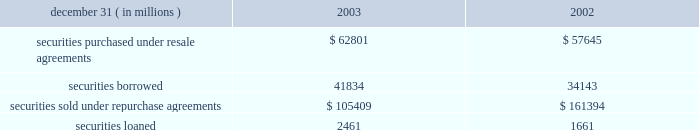Notes to consolidated financial statements j.p .
Morgan chase & co .
98 j.p .
Morgan chase & co .
/ 2003 annual report securities financing activities jpmorgan chase enters into resale agreements , repurchase agreements , securities borrowed transactions and securities loaned transactions primarily to finance the firm 2019s inventory positions , acquire securities to cover short positions and settle other securities obligations .
The firm also enters into these transactions to accommodate customers 2019 needs .
Securities purchased under resale agreements ( 201cresale agreements 201d ) and securities sold under repurchase agreements ( 201crepurchase agreements 201d ) are generally treated as collateralized financing transactions and are carried on the consolidated bal- ance sheet at the amounts the securities will be subsequently sold or repurchased , plus accrued interest .
Where appropriate , resale and repurchase agreements with the same counterparty are reported on a net basis in accordance with fin 41 .
Jpmorgan chase takes possession of securities purchased under resale agreements .
On a daily basis , jpmorgan chase monitors the market value of the underlying collateral received from its counterparties , consisting primarily of u.s .
And non-u.s .
Govern- ment and agency securities , and requests additional collateral from its counterparties when necessary .
Similar transactions that do not meet the sfas 140 definition of a repurchase agreement are accounted for as 201cbuys 201d and 201csells 201d rather than financing transactions .
These transactions are accounted for as a purchase ( sale ) of the underlying securities with a forward obligation to sell ( purchase ) the securities .
The forward purchase ( sale ) obligation , a derivative , is recorded on the consolidated balance sheet at its fair value , with changes in fair value recorded in trading revenue .
Notional amounts of these transactions accounted for as purchases under sfas 140 were $ 15 billion and $ 8 billion at december 31 , 2003 and 2002 , respectively .
Notional amounts of these transactions accounted for as sales under sfas 140 were $ 8 billion and $ 13 billion at december 31 , 2003 and 2002 , respectively .
Based on the short-term duration of these contracts , the unrealized gain or loss is insignificant .
Securities borrowed and securities lent are recorded at the amount of cash collateral advanced or received .
Securities bor- rowed consist primarily of government and equity securities .
Jpmorgan chase monitors the market value of the securities borrowed and lent on a daily basis and calls for additional col- lateral when appropriate .
Fees received or paid are recorded in interest income or interest expense. .
Note 10 jpmorgan chase pledges certain financial instruments it owns to collateralize repurchase agreements and other securities financ- ings .
Pledged securities that can be sold or repledged by the secured party are identified as financial instruments owned ( pledged to various parties ) on the consolidated balance sheet .
At december 31 , 2003 , the firm had received securities as col- lateral that can be repledged , delivered or otherwise used with a fair value of approximately $ 210 billion .
This collateral was gen- erally obtained under resale or securities-borrowing agreements .
Of these securities , approximately $ 197 billion was repledged , delivered or otherwise used , generally as collateral under repur- chase agreements , securities-lending agreements or to cover short sales .
Notes to consolidated financial statements j.p .
Morgan chase & co .
Loans are reported at the principal amount outstanding , net of the allowance for loan losses , unearned income and any net deferred loan fees .
Loans held for sale are carried at the lower of aggregate cost or fair value .
Loans are classified as 201ctrading 201d for secondary market trading activities where positions are bought and sold to make profits from short-term movements in price .
Loans held for trading purposes are included in trading assets and are carried at fair value , with the gains and losses included in trading revenue .
Interest income is recognized using the interest method , or on a basis approximating a level rate of return over the term of the loan .
Nonaccrual loans are those on which the accrual of interest is discontinued .
Loans ( other than certain consumer loans discussed below ) are placed on nonaccrual status immediately if , in the opinion of management , full payment of principal or interest is in doubt , or when principal or interest is 90 days or more past due and collateral , if any , is insufficient to cover prin- cipal and interest .
Interest accrued but not collected at the date a loan is placed on nonaccrual status is reversed against interest income .
In addition , the amortization of net deferred loan fees is suspended .
Interest income on nonaccrual loans is recognized only to the extent it is received in cash .
However , where there is doubt regarding the ultimate collectibility of loan principal , all cash thereafter received is applied to reduce the carrying value of the loan .
Loans are restored to accrual status only when interest and principal payments are brought current and future payments are reasonably assured .
Consumer loans are generally charged to the allowance for loan losses upon reaching specified stages of delinquency , in accor- dance with the federal financial institutions examination council ( 201cffiec 201d ) policy .
For example , credit card loans are charged off at the earlier of 180 days past due or within 60 days from receiving notification of the filing of bankruptcy .
Residential mortgage products are generally charged off to net realizable value at 180 days past due .
Other consumer products are gener- ally charged off ( to net realizable value if collateralized ) at 120 days past due .
Accrued interest on residential mortgage products , automobile financings and certain other consumer loans are accounted for in accordance with the nonaccrual loan policy note 11 .
In 2003 what was the ratio of the securities purchased under resale agreements to the \\nsecurities borrowed? 
Computations: (62801 / 41834)
Answer: 1.5012. 